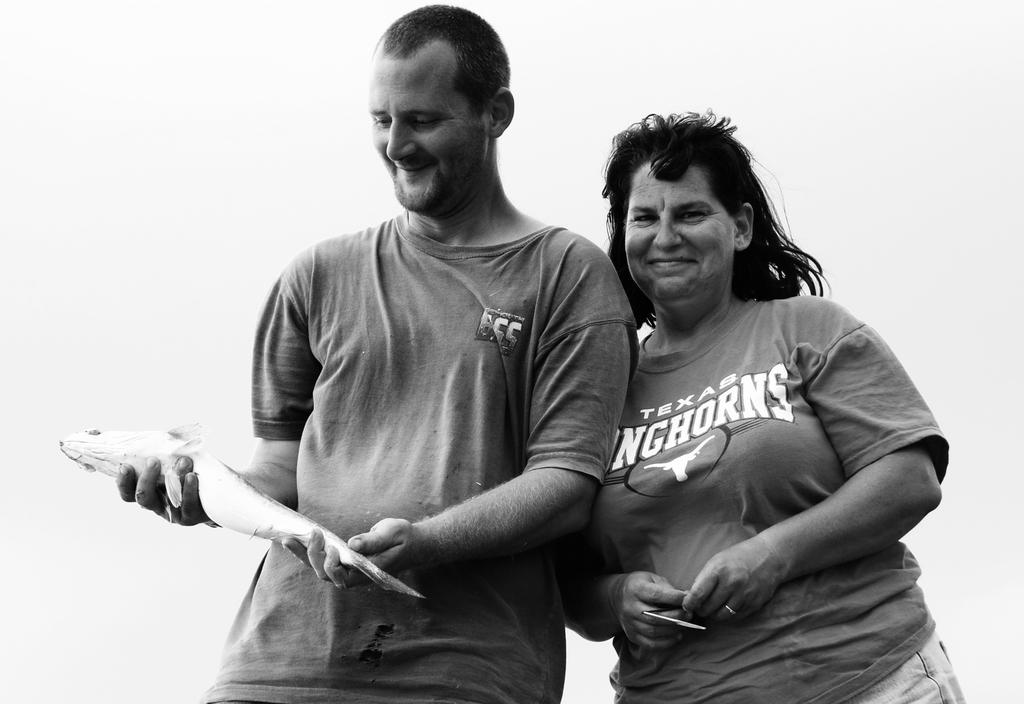How many people are present in the image? There are two people standing in the image. What is the man holding in the image? The man is holding a fish. What is the woman holding in the image? The woman is holding something, but the specific object is not mentioned in the facts. What is the color scheme of the image? The image is in black and white. What is the background color of the image? The background of the image is white. What type of ornament is on the table in the image? There is no table or ornament present in the image. What is the woman holding in her hand, and what is the texture of the eggnog? The woman is holding something, but the specific object is not mentioned in the facts, and there is no mention of eggnog in the image. 